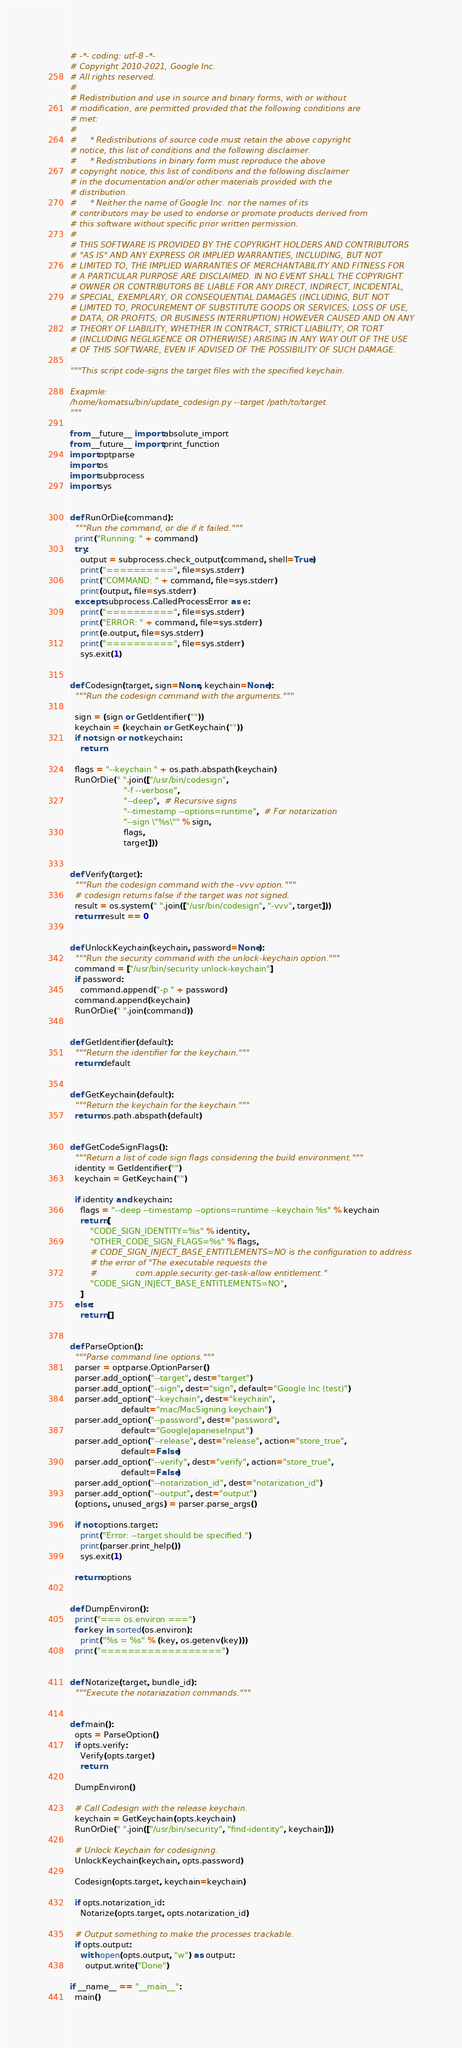<code> <loc_0><loc_0><loc_500><loc_500><_Python_># -*- coding: utf-8 -*-
# Copyright 2010-2021, Google Inc.
# All rights reserved.
#
# Redistribution and use in source and binary forms, with or without
# modification, are permitted provided that the following conditions are
# met:
#
#     * Redistributions of source code must retain the above copyright
# notice, this list of conditions and the following disclaimer.
#     * Redistributions in binary form must reproduce the above
# copyright notice, this list of conditions and the following disclaimer
# in the documentation and/or other materials provided with the
# distribution.
#     * Neither the name of Google Inc. nor the names of its
# contributors may be used to endorse or promote products derived from
# this software without specific prior written permission.
#
# THIS SOFTWARE IS PROVIDED BY THE COPYRIGHT HOLDERS AND CONTRIBUTORS
# "AS IS" AND ANY EXPRESS OR IMPLIED WARRANTIES, INCLUDING, BUT NOT
# LIMITED TO, THE IMPLIED WARRANTIES OF MERCHANTABILITY AND FITNESS FOR
# A PARTICULAR PURPOSE ARE DISCLAIMED. IN NO EVENT SHALL THE COPYRIGHT
# OWNER OR CONTRIBUTORS BE LIABLE FOR ANY DIRECT, INDIRECT, INCIDENTAL,
# SPECIAL, EXEMPLARY, OR CONSEQUENTIAL DAMAGES (INCLUDING, BUT NOT
# LIMITED TO, PROCUREMENT OF SUBSTITUTE GOODS OR SERVICES; LOSS OF USE,
# DATA, OR PROFITS; OR BUSINESS INTERRUPTION) HOWEVER CAUSED AND ON ANY
# THEORY OF LIABILITY, WHETHER IN CONTRACT, STRICT LIABILITY, OR TORT
# (INCLUDING NEGLIGENCE OR OTHERWISE) ARISING IN ANY WAY OUT OF THE USE
# OF THIS SOFTWARE, EVEN IF ADVISED OF THE POSSIBILITY OF SUCH DAMAGE.

"""This script code-signs the target files with the specified keychain.

Exapmle:
/home/komatsu/bin/update_codesign.py --target /path/to/target
"""

from __future__ import absolute_import
from __future__ import print_function
import optparse
import os
import subprocess
import sys


def RunOrDie(command):
  """Run the command, or die if it failed."""
  print("Running: " + command)
  try:
    output = subprocess.check_output(command, shell=True)
    print("==========", file=sys.stderr)
    print("COMMAND: " + command, file=sys.stderr)
    print(output, file=sys.stderr)
  except subprocess.CalledProcessError as e:
    print("==========", file=sys.stderr)
    print("ERROR: " + command, file=sys.stderr)
    print(e.output, file=sys.stderr)
    print("==========", file=sys.stderr)
    sys.exit(1)


def Codesign(target, sign=None, keychain=None):
  """Run the codesign command with the arguments."""

  sign = (sign or GetIdentifier(""))
  keychain = (keychain or GetKeychain(""))
  if not sign or not keychain:
    return

  flags = "--keychain " + os.path.abspath(keychain)
  RunOrDie(" ".join(["/usr/bin/codesign",
                     "-f --verbose",
                     "--deep",  # Recursive signs
                     "--timestamp --options=runtime",  # For notarization
                     "--sign \"%s\"" % sign,
                     flags,
                     target]))


def Verify(target):
  """Run the codesign command with the -vvv option."""
  # codesign returns false if the target was not signed.
  result = os.system(" ".join(["/usr/bin/codesign", "-vvv", target]))
  return result == 0


def UnlockKeychain(keychain, password=None):
  """Run the security command with the unlock-keychain option."""
  command = ["/usr/bin/security unlock-keychain"]
  if password:
    command.append("-p " + password)
  command.append(keychain)
  RunOrDie(" ".join(command))


def GetIdentifier(default):
  """Return the identifier for the keychain."""
  return default


def GetKeychain(default):
  """Return the keychain for the keychain."""
  return os.path.abspath(default)


def GetCodeSignFlags():
  """Return a list of code sign flags considering the build environment."""
  identity = GetIdentifier("")
  keychain = GetKeychain("")

  if identity and keychain:
    flags = "--deep --timestamp --options=runtime --keychain %s" % keychain
    return [
        "CODE_SIGN_IDENTITY=%s" % identity,
        "OTHER_CODE_SIGN_FLAGS=%s" % flags,
        # CODE_SIGN_INJECT_BASE_ENTITLEMENTS=NO is the configuration to address
        # the error of "The executable requests the
        #               com.apple.security.get-task-allow entitlement."
        "CODE_SIGN_INJECT_BASE_ENTITLEMENTS=NO",
    ]
  else:
    return []


def ParseOption():
  """Parse command line options."""
  parser = optparse.OptionParser()
  parser.add_option("--target", dest="target")
  parser.add_option("--sign", dest="sign", default="Google Inc (test)")
  parser.add_option("--keychain", dest="keychain",
                    default="mac/MacSigning.keychain")
  parser.add_option("--password", dest="password",
                    default="GoogleJapaneseInput")
  parser.add_option("--release", dest="release", action="store_true",
                    default=False)
  parser.add_option("--verify", dest="verify", action="store_true",
                    default=False)
  parser.add_option("--notarization_id", dest="notarization_id")
  parser.add_option("--output", dest="output")
  (options, unused_args) = parser.parse_args()

  if not options.target:
    print("Error: --target should be specified.")
    print(parser.print_help())
    sys.exit(1)

  return options


def DumpEnviron():
  print("=== os.environ ===")
  for key in sorted(os.environ):
    print("%s = %s" % (key, os.getenv(key)))
  print("==================")


def Notarize(target, bundle_id):
  """Execute the notariazation commands."""


def main():
  opts = ParseOption()
  if opts.verify:
    Verify(opts.target)
    return

  DumpEnviron()

  # Call Codesign with the release keychain.
  keychain = GetKeychain(opts.keychain)
  RunOrDie(" ".join(["/usr/bin/security", "find-identity", keychain]))

  # Unlock Keychain for codesigning.
  UnlockKeychain(keychain, opts.password)

  Codesign(opts.target, keychain=keychain)

  if opts.notarization_id:
    Notarize(opts.target, opts.notarization_id)

  # Output something to make the processes trackable.
  if opts.output:
    with open(opts.output, "w") as output:
      output.write("Done")

if __name__ == "__main__":
  main()
</code> 